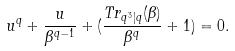<formula> <loc_0><loc_0><loc_500><loc_500>u ^ { q } + \frac { u } { \beta ^ { q - 1 } } + ( \frac { T r _ { q ^ { 3 } | q } ( \beta ) } { \beta ^ { q } } + 1 ) = 0 .</formula> 